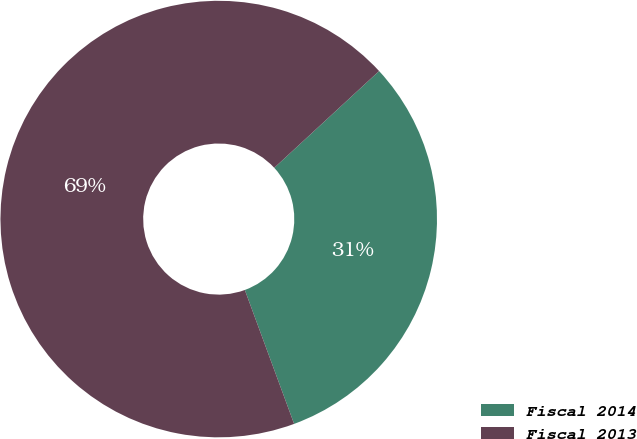Convert chart. <chart><loc_0><loc_0><loc_500><loc_500><pie_chart><fcel>Fiscal 2014<fcel>Fiscal 2013<nl><fcel>31.25%<fcel>68.75%<nl></chart> 